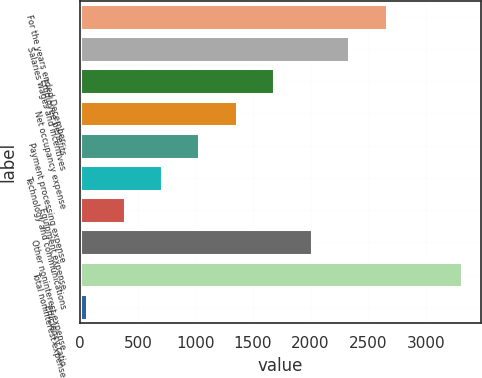<chart> <loc_0><loc_0><loc_500><loc_500><bar_chart><fcel>For the years ended December<fcel>Salaries wages and incentives<fcel>Employee benefits<fcel>Net occupancy expense<fcel>Payment processing expense<fcel>Technology and communications<fcel>Equipment expense<fcel>Other noninterest expense<fcel>Total noninterest expense<fcel>Efficiency ratio<nl><fcel>2660.84<fcel>2335.76<fcel>1685.6<fcel>1360.52<fcel>1035.44<fcel>710.36<fcel>385.28<fcel>2010.68<fcel>3311<fcel>60.2<nl></chart> 